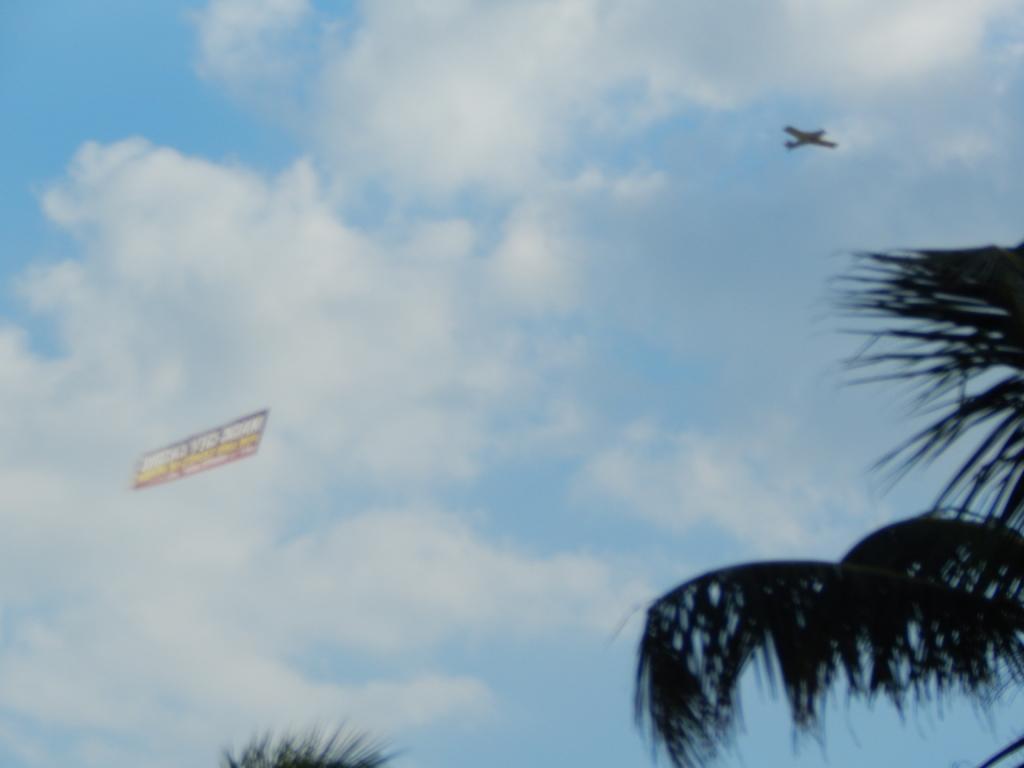Can you describe this image briefly? In this image we can see there are trees, aircraft and banner in the sky. 